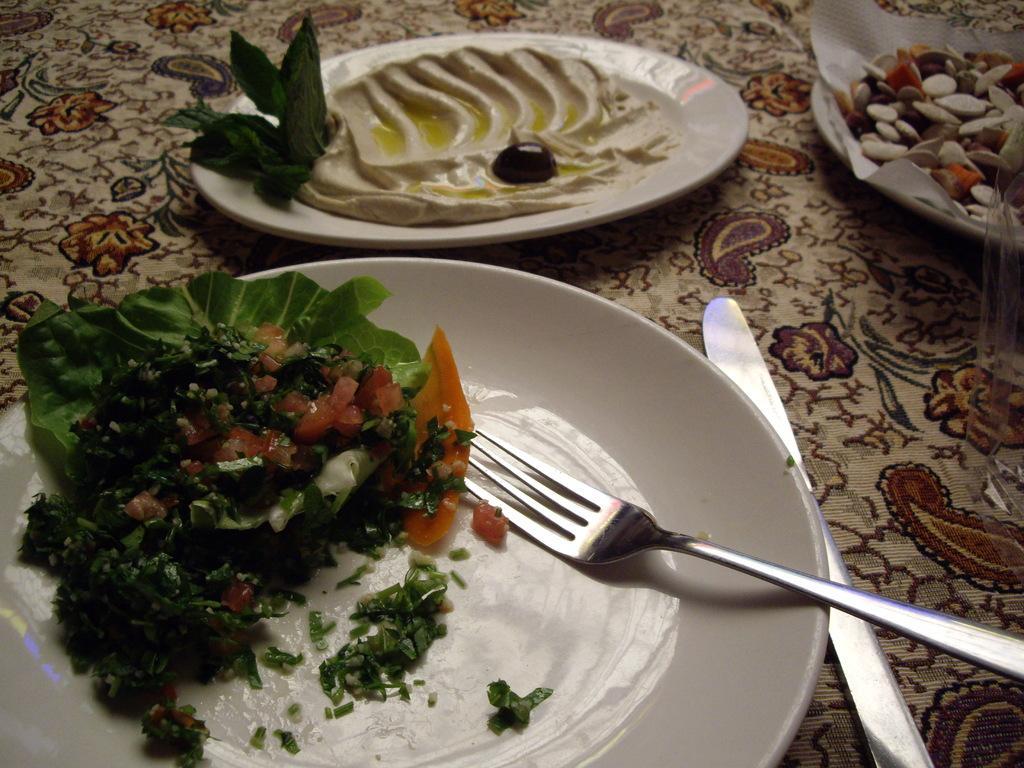Describe this image in one or two sentences. In this image we can see a cloth, on that there are plates with some food items. And we can see a spoon, knife, paper and few objects. 